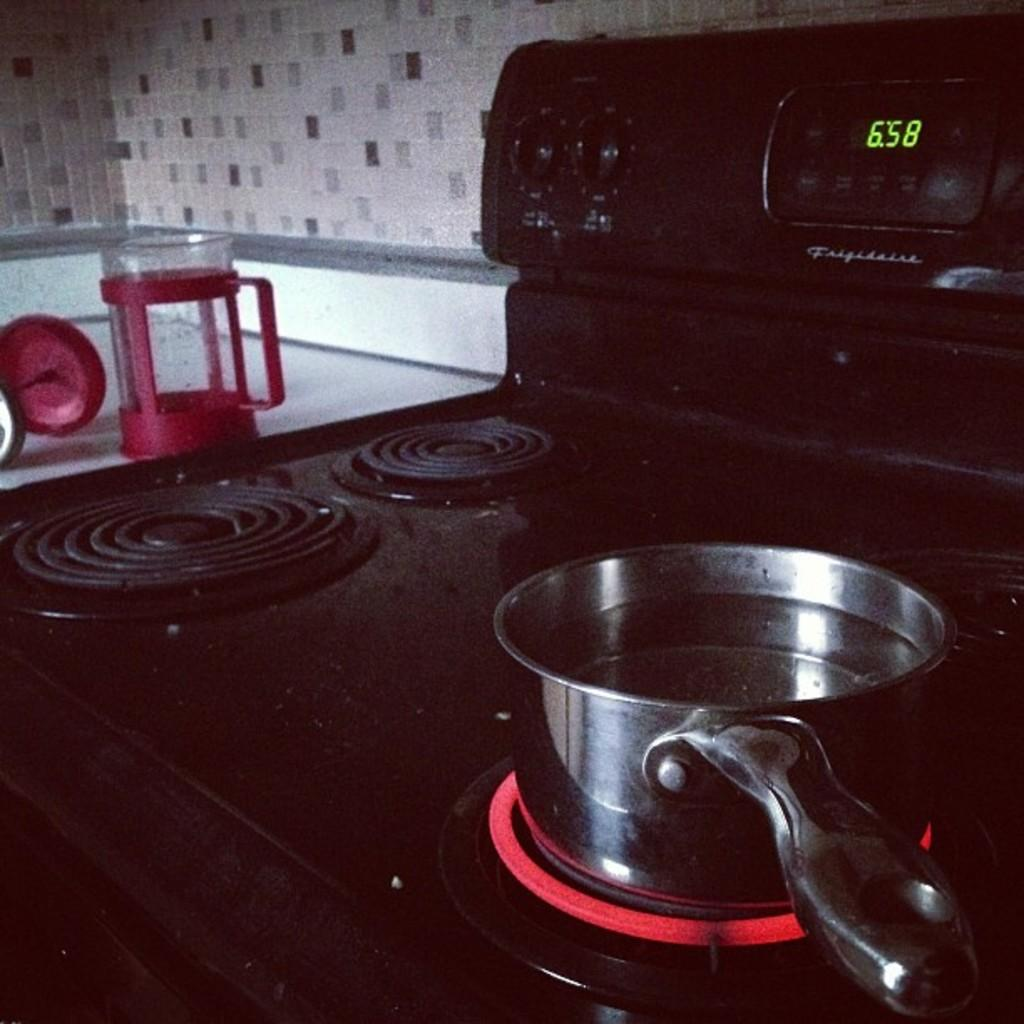Provide a one-sentence caption for the provided image. a pot warming on a hot stove burner by Frigidaire. 